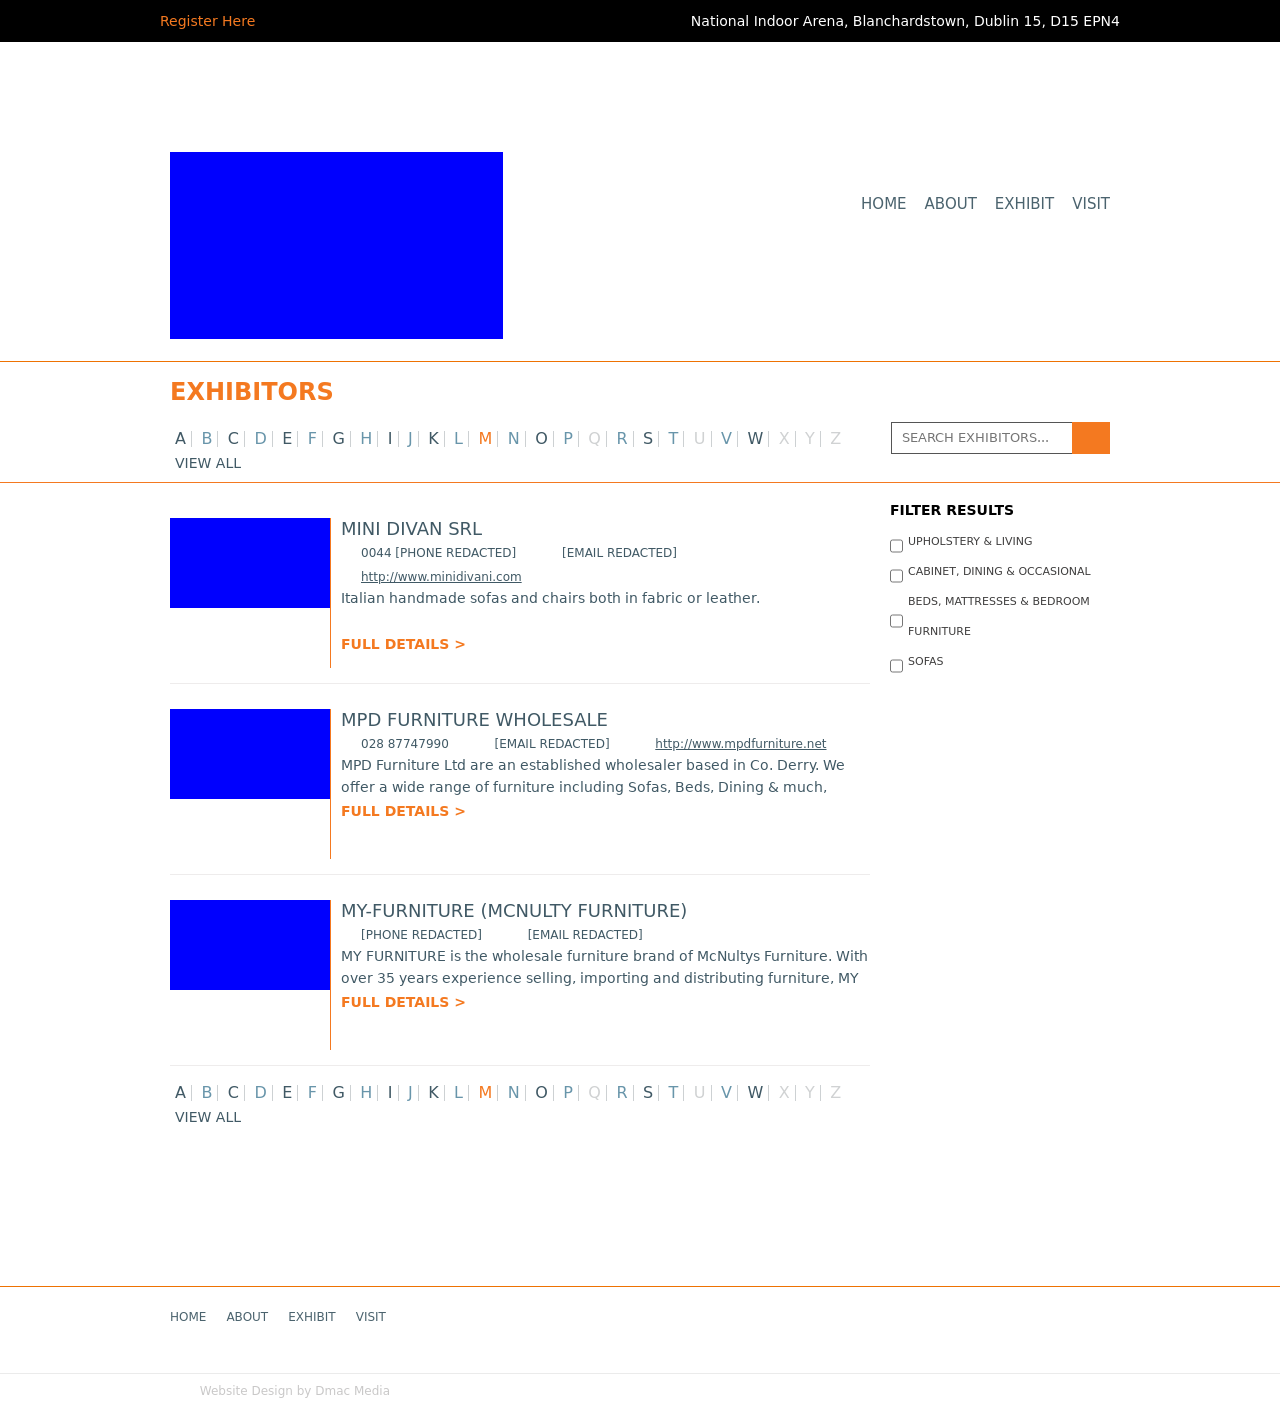Tell me more about the filtering system outlined in the right sidebar of the image. The filtering system in the sidebar includes checkboxes categorizing the exhibitors. Users can refine the visible listings by checking relevant categories such as 'Upholstery & Living' or 'Beds, Mattresses & Bedroom'. This feature helps in narrowing down choices by personal preference or specific interest areas within the furniture trade show.  Could there be an interactive element added to the exhibitor listings for users? Interactive elements could greatly improve engagement. For instance, adding a 'favorite' heart icon for users to save their preferred exhibitors could personalize the experience. Implementing a virtual booth tour with interactive elements like video presentations or 360-degree views of products would also provide a lively user interaction. 